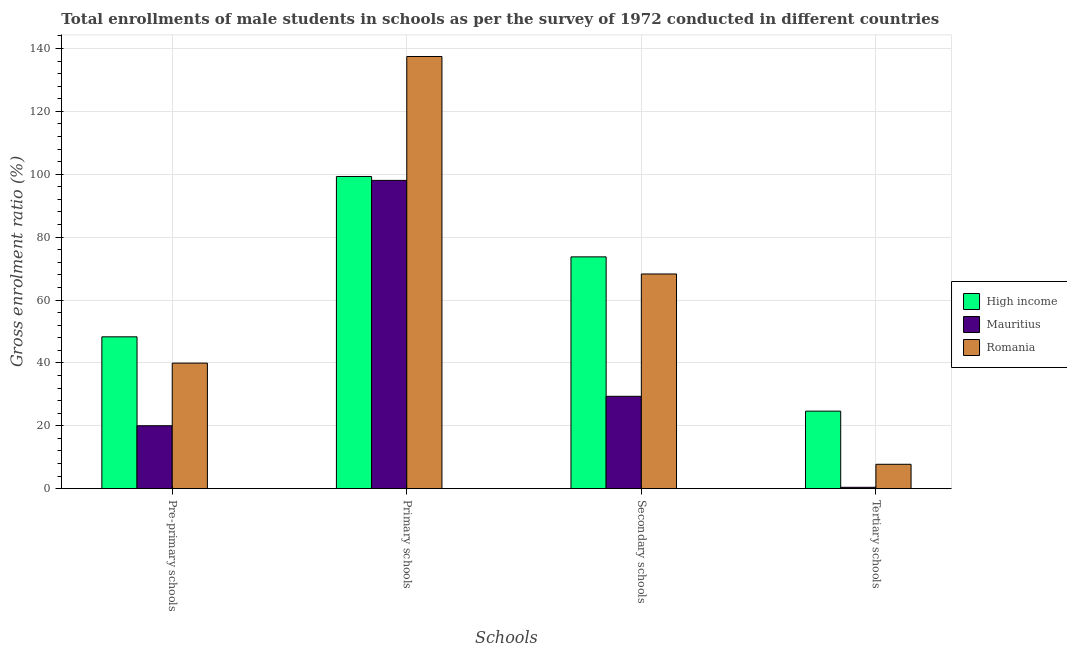Are the number of bars per tick equal to the number of legend labels?
Provide a short and direct response. Yes. How many bars are there on the 2nd tick from the left?
Your answer should be compact. 3. How many bars are there on the 4th tick from the right?
Offer a very short reply. 3. What is the label of the 2nd group of bars from the left?
Provide a succinct answer. Primary schools. What is the gross enrolment ratio(male) in secondary schools in Romania?
Offer a very short reply. 68.28. Across all countries, what is the maximum gross enrolment ratio(male) in tertiary schools?
Give a very brief answer. 24.66. Across all countries, what is the minimum gross enrolment ratio(male) in tertiary schools?
Your answer should be compact. 0.44. In which country was the gross enrolment ratio(male) in primary schools maximum?
Provide a short and direct response. Romania. In which country was the gross enrolment ratio(male) in secondary schools minimum?
Your answer should be very brief. Mauritius. What is the total gross enrolment ratio(male) in secondary schools in the graph?
Offer a terse response. 171.37. What is the difference between the gross enrolment ratio(male) in primary schools in Romania and that in Mauritius?
Give a very brief answer. 39.4. What is the difference between the gross enrolment ratio(male) in secondary schools in Romania and the gross enrolment ratio(male) in primary schools in Mauritius?
Give a very brief answer. -29.77. What is the average gross enrolment ratio(male) in secondary schools per country?
Give a very brief answer. 57.12. What is the difference between the gross enrolment ratio(male) in tertiary schools and gross enrolment ratio(male) in pre-primary schools in High income?
Offer a terse response. -23.63. In how many countries, is the gross enrolment ratio(male) in primary schools greater than 24 %?
Offer a terse response. 3. What is the ratio of the gross enrolment ratio(male) in tertiary schools in Mauritius to that in High income?
Ensure brevity in your answer.  0.02. Is the gross enrolment ratio(male) in primary schools in Romania less than that in High income?
Provide a succinct answer. No. What is the difference between the highest and the second highest gross enrolment ratio(male) in primary schools?
Your answer should be very brief. 38.16. What is the difference between the highest and the lowest gross enrolment ratio(male) in primary schools?
Offer a terse response. 39.4. Is the sum of the gross enrolment ratio(male) in pre-primary schools in High income and Romania greater than the maximum gross enrolment ratio(male) in tertiary schools across all countries?
Your answer should be very brief. Yes. Is it the case that in every country, the sum of the gross enrolment ratio(male) in secondary schools and gross enrolment ratio(male) in tertiary schools is greater than the sum of gross enrolment ratio(male) in pre-primary schools and gross enrolment ratio(male) in primary schools?
Offer a terse response. Yes. What does the 2nd bar from the left in Secondary schools represents?
Offer a very short reply. Mauritius. What does the 1st bar from the right in Primary schools represents?
Your answer should be compact. Romania. How many bars are there?
Your answer should be compact. 12. What is the difference between two consecutive major ticks on the Y-axis?
Give a very brief answer. 20. Are the values on the major ticks of Y-axis written in scientific E-notation?
Give a very brief answer. No. Does the graph contain any zero values?
Provide a short and direct response. No. Where does the legend appear in the graph?
Provide a succinct answer. Center right. How many legend labels are there?
Ensure brevity in your answer.  3. What is the title of the graph?
Offer a terse response. Total enrollments of male students in schools as per the survey of 1972 conducted in different countries. What is the label or title of the X-axis?
Ensure brevity in your answer.  Schools. What is the Gross enrolment ratio (%) in High income in Pre-primary schools?
Provide a short and direct response. 48.29. What is the Gross enrolment ratio (%) of Mauritius in Pre-primary schools?
Your answer should be very brief. 20.02. What is the Gross enrolment ratio (%) of Romania in Pre-primary schools?
Keep it short and to the point. 39.93. What is the Gross enrolment ratio (%) in High income in Primary schools?
Offer a terse response. 99.28. What is the Gross enrolment ratio (%) of Mauritius in Primary schools?
Provide a short and direct response. 98.04. What is the Gross enrolment ratio (%) of Romania in Primary schools?
Make the answer very short. 137.44. What is the Gross enrolment ratio (%) of High income in Secondary schools?
Give a very brief answer. 73.72. What is the Gross enrolment ratio (%) in Mauritius in Secondary schools?
Offer a very short reply. 29.38. What is the Gross enrolment ratio (%) in Romania in Secondary schools?
Ensure brevity in your answer.  68.28. What is the Gross enrolment ratio (%) of High income in Tertiary schools?
Provide a succinct answer. 24.66. What is the Gross enrolment ratio (%) of Mauritius in Tertiary schools?
Give a very brief answer. 0.44. What is the Gross enrolment ratio (%) of Romania in Tertiary schools?
Your answer should be compact. 7.76. Across all Schools, what is the maximum Gross enrolment ratio (%) of High income?
Provide a succinct answer. 99.28. Across all Schools, what is the maximum Gross enrolment ratio (%) of Mauritius?
Give a very brief answer. 98.04. Across all Schools, what is the maximum Gross enrolment ratio (%) in Romania?
Your answer should be very brief. 137.44. Across all Schools, what is the minimum Gross enrolment ratio (%) in High income?
Your answer should be very brief. 24.66. Across all Schools, what is the minimum Gross enrolment ratio (%) in Mauritius?
Ensure brevity in your answer.  0.44. Across all Schools, what is the minimum Gross enrolment ratio (%) in Romania?
Your answer should be very brief. 7.76. What is the total Gross enrolment ratio (%) of High income in the graph?
Your response must be concise. 245.95. What is the total Gross enrolment ratio (%) of Mauritius in the graph?
Offer a terse response. 147.87. What is the total Gross enrolment ratio (%) of Romania in the graph?
Ensure brevity in your answer.  253.4. What is the difference between the Gross enrolment ratio (%) in High income in Pre-primary schools and that in Primary schools?
Provide a short and direct response. -50.99. What is the difference between the Gross enrolment ratio (%) in Mauritius in Pre-primary schools and that in Primary schools?
Provide a succinct answer. -78.03. What is the difference between the Gross enrolment ratio (%) of Romania in Pre-primary schools and that in Primary schools?
Offer a terse response. -97.51. What is the difference between the Gross enrolment ratio (%) in High income in Pre-primary schools and that in Secondary schools?
Your answer should be compact. -25.43. What is the difference between the Gross enrolment ratio (%) of Mauritius in Pre-primary schools and that in Secondary schools?
Provide a succinct answer. -9.36. What is the difference between the Gross enrolment ratio (%) in Romania in Pre-primary schools and that in Secondary schools?
Ensure brevity in your answer.  -28.35. What is the difference between the Gross enrolment ratio (%) of High income in Pre-primary schools and that in Tertiary schools?
Provide a short and direct response. 23.63. What is the difference between the Gross enrolment ratio (%) of Mauritius in Pre-primary schools and that in Tertiary schools?
Offer a terse response. 19.58. What is the difference between the Gross enrolment ratio (%) in Romania in Pre-primary schools and that in Tertiary schools?
Provide a succinct answer. 32.17. What is the difference between the Gross enrolment ratio (%) of High income in Primary schools and that in Secondary schools?
Keep it short and to the point. 25.56. What is the difference between the Gross enrolment ratio (%) in Mauritius in Primary schools and that in Secondary schools?
Give a very brief answer. 68.67. What is the difference between the Gross enrolment ratio (%) of Romania in Primary schools and that in Secondary schools?
Ensure brevity in your answer.  69.17. What is the difference between the Gross enrolment ratio (%) in High income in Primary schools and that in Tertiary schools?
Provide a short and direct response. 74.63. What is the difference between the Gross enrolment ratio (%) of Mauritius in Primary schools and that in Tertiary schools?
Your answer should be very brief. 97.61. What is the difference between the Gross enrolment ratio (%) in Romania in Primary schools and that in Tertiary schools?
Give a very brief answer. 129.69. What is the difference between the Gross enrolment ratio (%) in High income in Secondary schools and that in Tertiary schools?
Provide a short and direct response. 49.06. What is the difference between the Gross enrolment ratio (%) in Mauritius in Secondary schools and that in Tertiary schools?
Give a very brief answer. 28.94. What is the difference between the Gross enrolment ratio (%) in Romania in Secondary schools and that in Tertiary schools?
Your response must be concise. 60.52. What is the difference between the Gross enrolment ratio (%) in High income in Pre-primary schools and the Gross enrolment ratio (%) in Mauritius in Primary schools?
Make the answer very short. -49.75. What is the difference between the Gross enrolment ratio (%) of High income in Pre-primary schools and the Gross enrolment ratio (%) of Romania in Primary schools?
Your response must be concise. -89.15. What is the difference between the Gross enrolment ratio (%) of Mauritius in Pre-primary schools and the Gross enrolment ratio (%) of Romania in Primary schools?
Provide a short and direct response. -117.43. What is the difference between the Gross enrolment ratio (%) in High income in Pre-primary schools and the Gross enrolment ratio (%) in Mauritius in Secondary schools?
Provide a short and direct response. 18.91. What is the difference between the Gross enrolment ratio (%) of High income in Pre-primary schools and the Gross enrolment ratio (%) of Romania in Secondary schools?
Offer a terse response. -19.99. What is the difference between the Gross enrolment ratio (%) in Mauritius in Pre-primary schools and the Gross enrolment ratio (%) in Romania in Secondary schools?
Ensure brevity in your answer.  -48.26. What is the difference between the Gross enrolment ratio (%) of High income in Pre-primary schools and the Gross enrolment ratio (%) of Mauritius in Tertiary schools?
Ensure brevity in your answer.  47.85. What is the difference between the Gross enrolment ratio (%) of High income in Pre-primary schools and the Gross enrolment ratio (%) of Romania in Tertiary schools?
Provide a short and direct response. 40.53. What is the difference between the Gross enrolment ratio (%) in Mauritius in Pre-primary schools and the Gross enrolment ratio (%) in Romania in Tertiary schools?
Provide a short and direct response. 12.26. What is the difference between the Gross enrolment ratio (%) in High income in Primary schools and the Gross enrolment ratio (%) in Mauritius in Secondary schools?
Provide a short and direct response. 69.91. What is the difference between the Gross enrolment ratio (%) in High income in Primary schools and the Gross enrolment ratio (%) in Romania in Secondary schools?
Your answer should be compact. 31.01. What is the difference between the Gross enrolment ratio (%) in Mauritius in Primary schools and the Gross enrolment ratio (%) in Romania in Secondary schools?
Keep it short and to the point. 29.77. What is the difference between the Gross enrolment ratio (%) of High income in Primary schools and the Gross enrolment ratio (%) of Mauritius in Tertiary schools?
Offer a terse response. 98.84. What is the difference between the Gross enrolment ratio (%) in High income in Primary schools and the Gross enrolment ratio (%) in Romania in Tertiary schools?
Provide a succinct answer. 91.52. What is the difference between the Gross enrolment ratio (%) in Mauritius in Primary schools and the Gross enrolment ratio (%) in Romania in Tertiary schools?
Your answer should be compact. 90.29. What is the difference between the Gross enrolment ratio (%) of High income in Secondary schools and the Gross enrolment ratio (%) of Mauritius in Tertiary schools?
Ensure brevity in your answer.  73.28. What is the difference between the Gross enrolment ratio (%) in High income in Secondary schools and the Gross enrolment ratio (%) in Romania in Tertiary schools?
Your answer should be very brief. 65.96. What is the difference between the Gross enrolment ratio (%) of Mauritius in Secondary schools and the Gross enrolment ratio (%) of Romania in Tertiary schools?
Give a very brief answer. 21.62. What is the average Gross enrolment ratio (%) of High income per Schools?
Make the answer very short. 61.49. What is the average Gross enrolment ratio (%) in Mauritius per Schools?
Provide a succinct answer. 36.97. What is the average Gross enrolment ratio (%) of Romania per Schools?
Offer a terse response. 63.35. What is the difference between the Gross enrolment ratio (%) in High income and Gross enrolment ratio (%) in Mauritius in Pre-primary schools?
Offer a very short reply. 28.27. What is the difference between the Gross enrolment ratio (%) in High income and Gross enrolment ratio (%) in Romania in Pre-primary schools?
Give a very brief answer. 8.36. What is the difference between the Gross enrolment ratio (%) of Mauritius and Gross enrolment ratio (%) of Romania in Pre-primary schools?
Provide a succinct answer. -19.91. What is the difference between the Gross enrolment ratio (%) in High income and Gross enrolment ratio (%) in Mauritius in Primary schools?
Offer a very short reply. 1.24. What is the difference between the Gross enrolment ratio (%) in High income and Gross enrolment ratio (%) in Romania in Primary schools?
Offer a terse response. -38.16. What is the difference between the Gross enrolment ratio (%) in Mauritius and Gross enrolment ratio (%) in Romania in Primary schools?
Your answer should be compact. -39.4. What is the difference between the Gross enrolment ratio (%) of High income and Gross enrolment ratio (%) of Mauritius in Secondary schools?
Make the answer very short. 44.34. What is the difference between the Gross enrolment ratio (%) of High income and Gross enrolment ratio (%) of Romania in Secondary schools?
Make the answer very short. 5.44. What is the difference between the Gross enrolment ratio (%) in Mauritius and Gross enrolment ratio (%) in Romania in Secondary schools?
Offer a terse response. -38.9. What is the difference between the Gross enrolment ratio (%) in High income and Gross enrolment ratio (%) in Mauritius in Tertiary schools?
Provide a short and direct response. 24.22. What is the difference between the Gross enrolment ratio (%) in High income and Gross enrolment ratio (%) in Romania in Tertiary schools?
Provide a short and direct response. 16.9. What is the difference between the Gross enrolment ratio (%) of Mauritius and Gross enrolment ratio (%) of Romania in Tertiary schools?
Your answer should be very brief. -7.32. What is the ratio of the Gross enrolment ratio (%) in High income in Pre-primary schools to that in Primary schools?
Your answer should be compact. 0.49. What is the ratio of the Gross enrolment ratio (%) in Mauritius in Pre-primary schools to that in Primary schools?
Ensure brevity in your answer.  0.2. What is the ratio of the Gross enrolment ratio (%) of Romania in Pre-primary schools to that in Primary schools?
Make the answer very short. 0.29. What is the ratio of the Gross enrolment ratio (%) in High income in Pre-primary schools to that in Secondary schools?
Your response must be concise. 0.66. What is the ratio of the Gross enrolment ratio (%) in Mauritius in Pre-primary schools to that in Secondary schools?
Give a very brief answer. 0.68. What is the ratio of the Gross enrolment ratio (%) in Romania in Pre-primary schools to that in Secondary schools?
Your answer should be very brief. 0.58. What is the ratio of the Gross enrolment ratio (%) in High income in Pre-primary schools to that in Tertiary schools?
Give a very brief answer. 1.96. What is the ratio of the Gross enrolment ratio (%) in Mauritius in Pre-primary schools to that in Tertiary schools?
Offer a very short reply. 45.69. What is the ratio of the Gross enrolment ratio (%) of Romania in Pre-primary schools to that in Tertiary schools?
Give a very brief answer. 5.15. What is the ratio of the Gross enrolment ratio (%) in High income in Primary schools to that in Secondary schools?
Give a very brief answer. 1.35. What is the ratio of the Gross enrolment ratio (%) in Mauritius in Primary schools to that in Secondary schools?
Provide a succinct answer. 3.34. What is the ratio of the Gross enrolment ratio (%) in Romania in Primary schools to that in Secondary schools?
Your answer should be very brief. 2.01. What is the ratio of the Gross enrolment ratio (%) in High income in Primary schools to that in Tertiary schools?
Your answer should be compact. 4.03. What is the ratio of the Gross enrolment ratio (%) of Mauritius in Primary schools to that in Tertiary schools?
Provide a succinct answer. 223.79. What is the ratio of the Gross enrolment ratio (%) in Romania in Primary schools to that in Tertiary schools?
Provide a succinct answer. 17.72. What is the ratio of the Gross enrolment ratio (%) in High income in Secondary schools to that in Tertiary schools?
Offer a terse response. 2.99. What is the ratio of the Gross enrolment ratio (%) in Mauritius in Secondary schools to that in Tertiary schools?
Give a very brief answer. 67.05. What is the ratio of the Gross enrolment ratio (%) of Romania in Secondary schools to that in Tertiary schools?
Offer a very short reply. 8.8. What is the difference between the highest and the second highest Gross enrolment ratio (%) of High income?
Your answer should be compact. 25.56. What is the difference between the highest and the second highest Gross enrolment ratio (%) of Mauritius?
Give a very brief answer. 68.67. What is the difference between the highest and the second highest Gross enrolment ratio (%) of Romania?
Provide a succinct answer. 69.17. What is the difference between the highest and the lowest Gross enrolment ratio (%) in High income?
Offer a very short reply. 74.63. What is the difference between the highest and the lowest Gross enrolment ratio (%) in Mauritius?
Provide a succinct answer. 97.61. What is the difference between the highest and the lowest Gross enrolment ratio (%) of Romania?
Give a very brief answer. 129.69. 